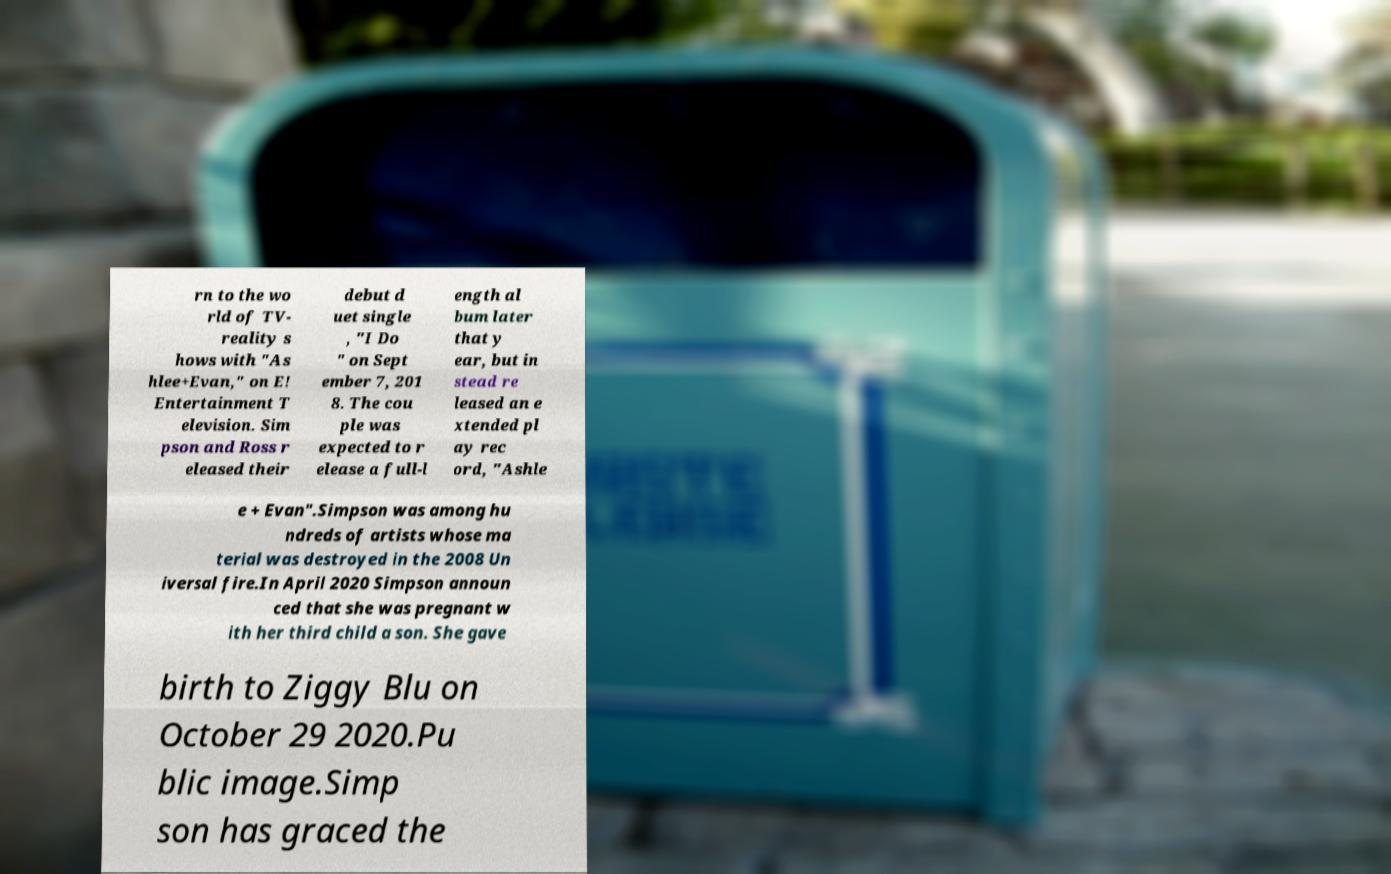What messages or text are displayed in this image? I need them in a readable, typed format. rn to the wo rld of TV- reality s hows with "As hlee+Evan," on E! Entertainment T elevision. Sim pson and Ross r eleased their debut d uet single , "I Do " on Sept ember 7, 201 8. The cou ple was expected to r elease a full-l ength al bum later that y ear, but in stead re leased an e xtended pl ay rec ord, "Ashle e + Evan".Simpson was among hu ndreds of artists whose ma terial was destroyed in the 2008 Un iversal fire.In April 2020 Simpson announ ced that she was pregnant w ith her third child a son. She gave birth to Ziggy Blu on October 29 2020.Pu blic image.Simp son has graced the 